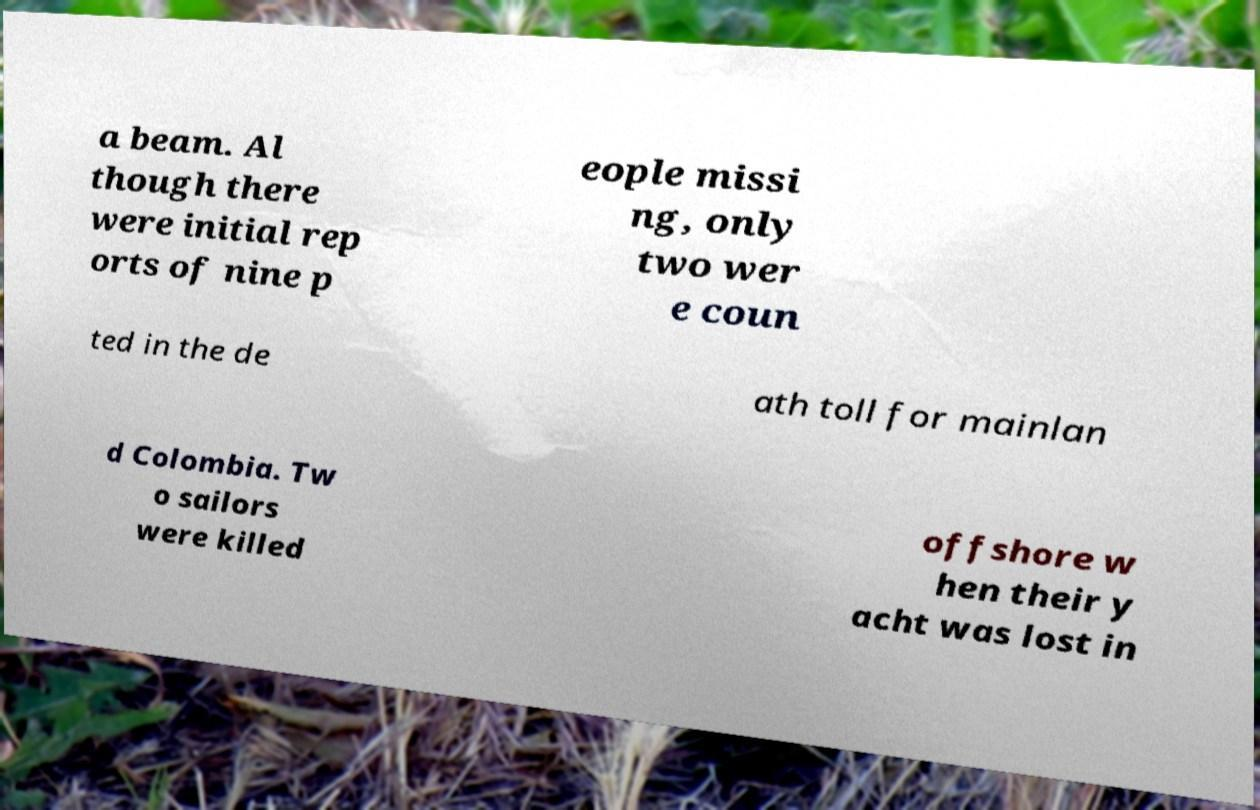I need the written content from this picture converted into text. Can you do that? a beam. Al though there were initial rep orts of nine p eople missi ng, only two wer e coun ted in the de ath toll for mainlan d Colombia. Tw o sailors were killed offshore w hen their y acht was lost in 